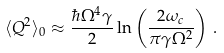<formula> <loc_0><loc_0><loc_500><loc_500>\langle Q ^ { 2 } \rangle _ { 0 } \approx \frac { \hbar { \Omega } ^ { 4 } \gamma } { 2 } \ln \left ( \frac { 2 \omega _ { c } } { \pi \gamma \Omega ^ { 2 } } \right ) \, .</formula> 